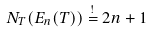<formula> <loc_0><loc_0><loc_500><loc_500>N _ { T } ( E _ { n } ( T ) ) \stackrel { ! } { = } 2 n + 1</formula> 